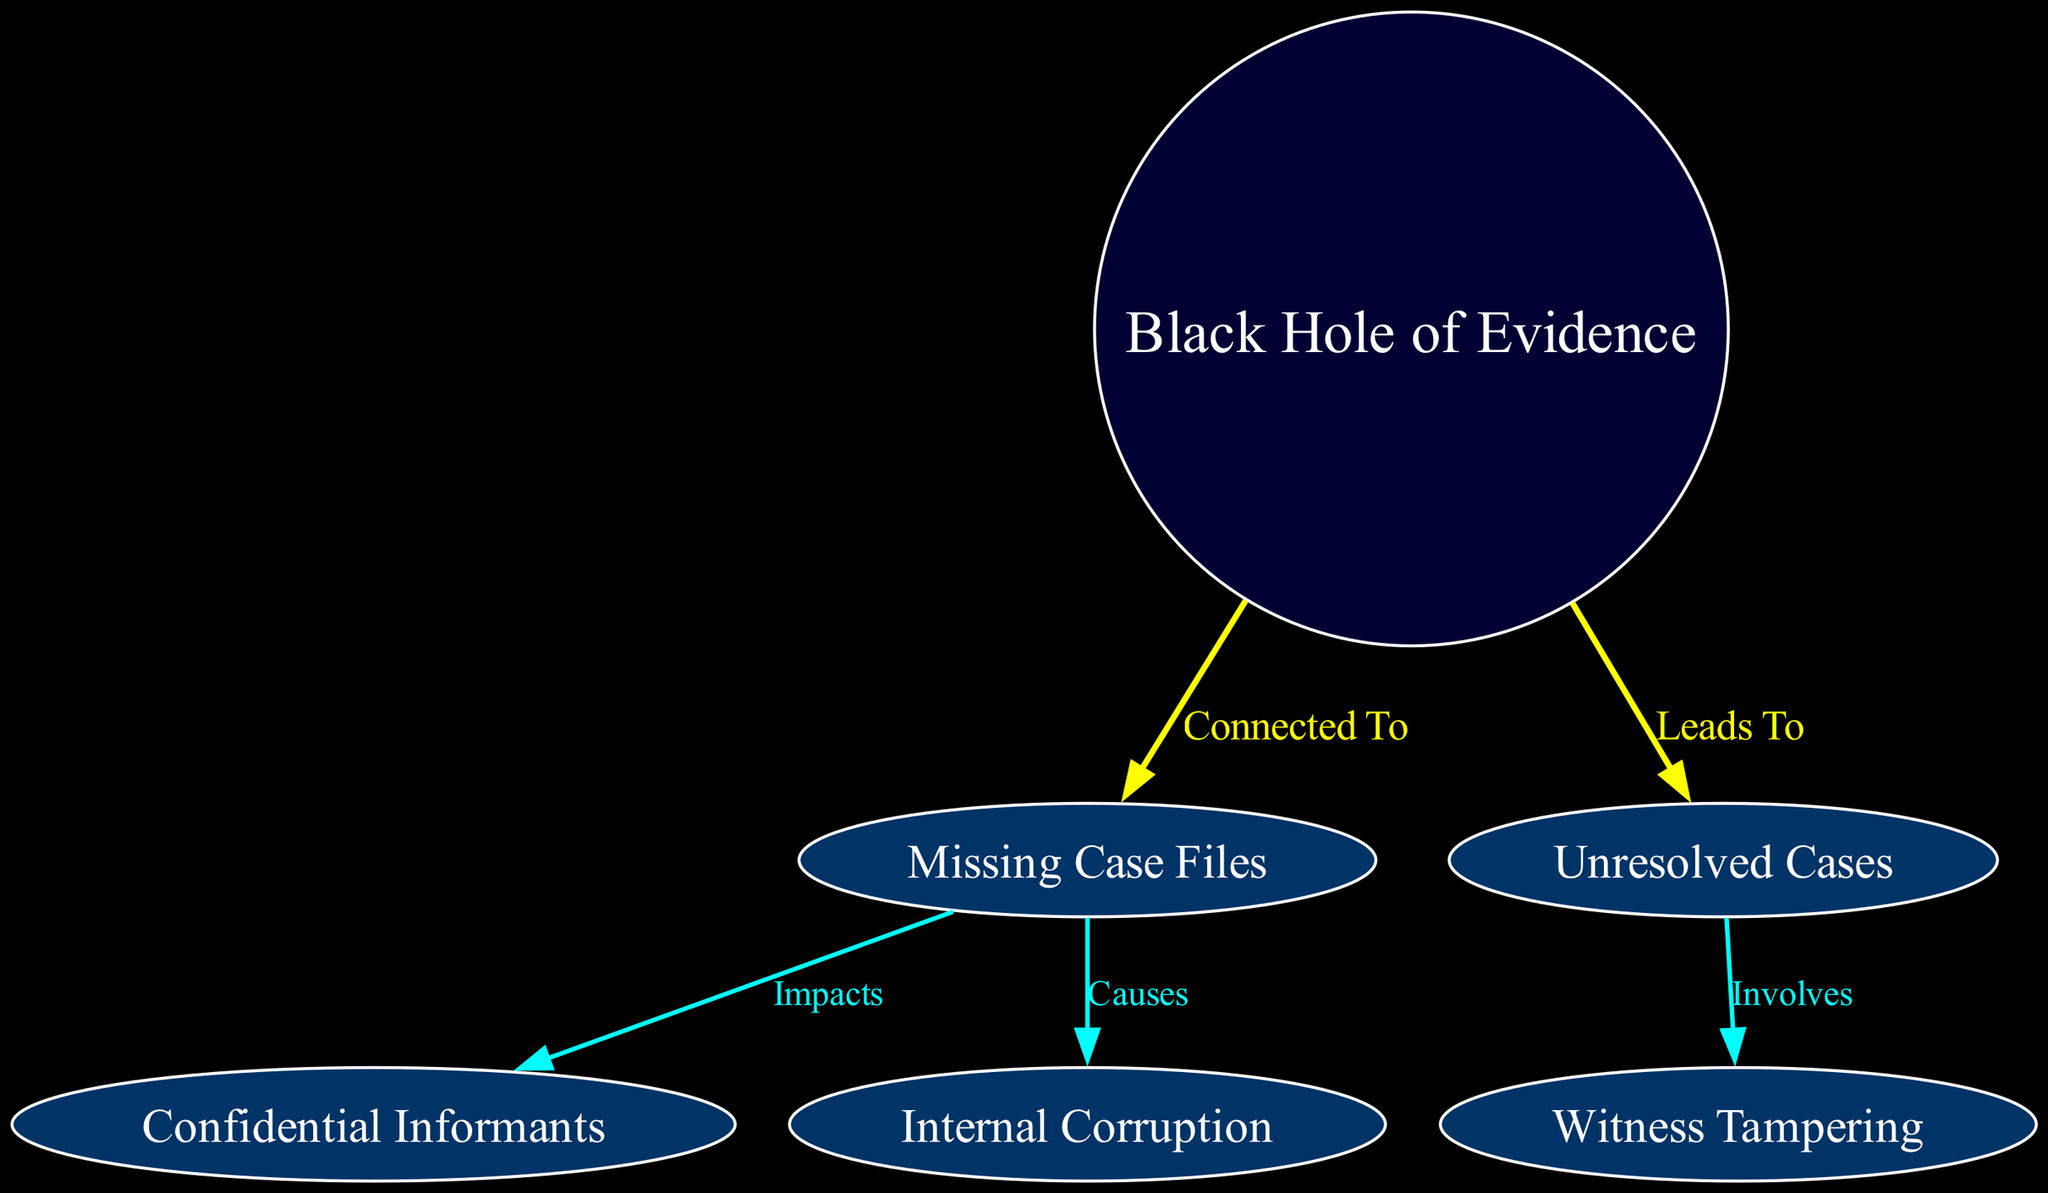What is the central node in this diagram? The central node in the diagram is labeled "Black Hole of Evidence." This is identified as it is the only node with the type "center," which is visually distinct from the satellite nodes.
Answer: Black Hole of Evidence How many total nodes are in the diagram? To find the total number of nodes, we count all the entries listed in the "nodes" section of the data. There are six nodes: one center node and five satellite nodes.
Answer: 6 Which satellite node is connected to "Missing Case Files"? The node that is connected to "Missing Case Files" is "Confidential Informants" and "Internal Corruption." They are both directly linked via the edges labeled “Impacts” and “Causes.”
Answer: Confidential Informants What does "Black Hole of Evidence" lead to? "Black Hole of Evidence" leads to "Unresolved Cases." This is indicated by the edge that connects the central node to this satellite node with the label "Leads To."
Answer: Unresolved Cases Which node involves "Witness Tampering"? The satellite node that involves "Witness Tampering" is "Unresolved Cases." The relationship is indicated by the edge labeled "Involves" stemming from "Unresolved Cases" to "Witness Tampering."
Answer: Unresolved Cases What are the types of relationships depicted in the diagram? The diagram depicts two types of relationships: "main" and "secondary." The "main" relationships are characterized by brighter colors and thicker lines, while "secondary" relationships have a different color and thinner lines.
Answer: Main and secondary How many secondary edges connect to "Missing Case Files"? There are two secondary edges that connect to "Missing Case Files," corresponding to relationships with "Confidential Informants" and "Internal Corruption." Each edge illustrates an impact or causation from the main satellite node.
Answer: 2 Which edge connects "Black Hole of Evidence" to "Missing Case Files"? The edge that connects "Black Hole of Evidence" to "Missing Case Files" is labeled "Connected To." This is a primary relationship indicated by its bold yellow color in the diagram.
Answer: Connected To What type of diagram is this? This diagram is an astronomy diagram, which typically illustrates relationships and connections among various entities using spatial representation. It is specifically themed around the concept of evidence in unresolved law enforcement cases.
Answer: Astronomy Diagram 